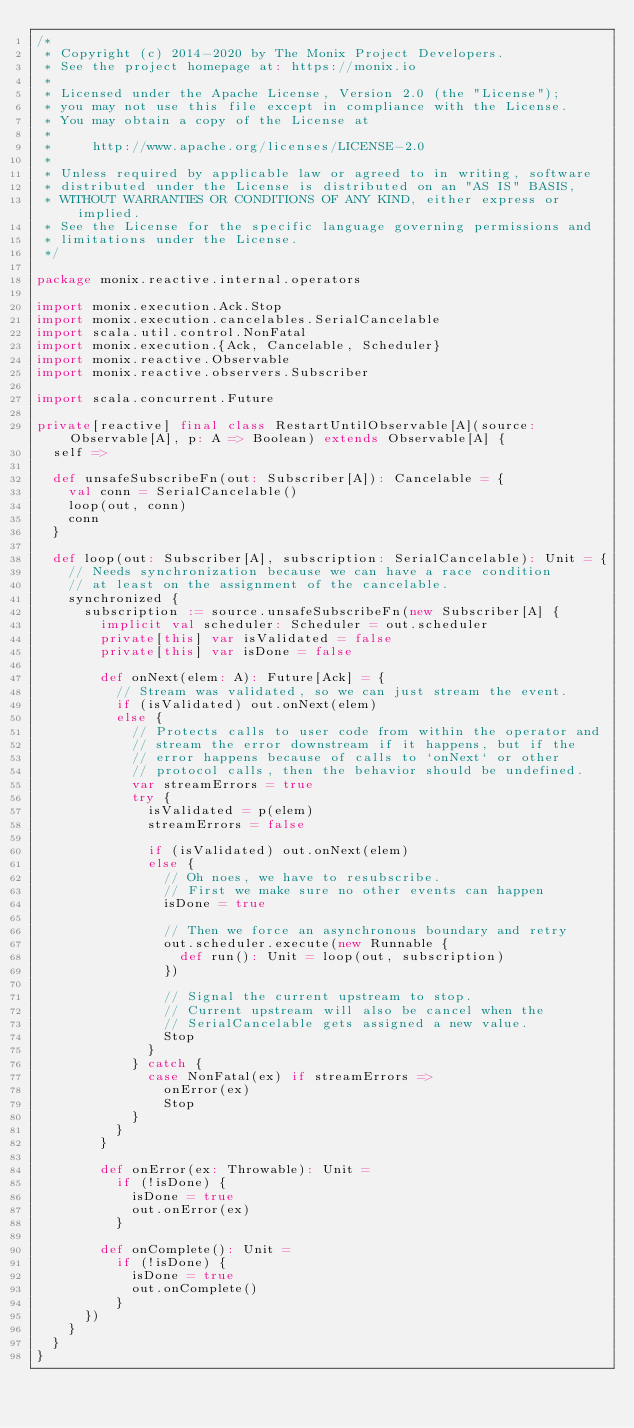<code> <loc_0><loc_0><loc_500><loc_500><_Scala_>/*
 * Copyright (c) 2014-2020 by The Monix Project Developers.
 * See the project homepage at: https://monix.io
 *
 * Licensed under the Apache License, Version 2.0 (the "License");
 * you may not use this file except in compliance with the License.
 * You may obtain a copy of the License at
 *
 *     http://www.apache.org/licenses/LICENSE-2.0
 *
 * Unless required by applicable law or agreed to in writing, software
 * distributed under the License is distributed on an "AS IS" BASIS,
 * WITHOUT WARRANTIES OR CONDITIONS OF ANY KIND, either express or implied.
 * See the License for the specific language governing permissions and
 * limitations under the License.
 */

package monix.reactive.internal.operators

import monix.execution.Ack.Stop
import monix.execution.cancelables.SerialCancelable
import scala.util.control.NonFatal
import monix.execution.{Ack, Cancelable, Scheduler}
import monix.reactive.Observable
import monix.reactive.observers.Subscriber

import scala.concurrent.Future

private[reactive] final class RestartUntilObservable[A](source: Observable[A], p: A => Boolean) extends Observable[A] {
  self =>

  def unsafeSubscribeFn(out: Subscriber[A]): Cancelable = {
    val conn = SerialCancelable()
    loop(out, conn)
    conn
  }

  def loop(out: Subscriber[A], subscription: SerialCancelable): Unit = {
    // Needs synchronization because we can have a race condition
    // at least on the assignment of the cancelable.
    synchronized {
      subscription := source.unsafeSubscribeFn(new Subscriber[A] {
        implicit val scheduler: Scheduler = out.scheduler
        private[this] var isValidated = false
        private[this] var isDone = false

        def onNext(elem: A): Future[Ack] = {
          // Stream was validated, so we can just stream the event.
          if (isValidated) out.onNext(elem)
          else {
            // Protects calls to user code from within the operator and
            // stream the error downstream if it happens, but if the
            // error happens because of calls to `onNext` or other
            // protocol calls, then the behavior should be undefined.
            var streamErrors = true
            try {
              isValidated = p(elem)
              streamErrors = false

              if (isValidated) out.onNext(elem)
              else {
                // Oh noes, we have to resubscribe.
                // First we make sure no other events can happen
                isDone = true

                // Then we force an asynchronous boundary and retry
                out.scheduler.execute(new Runnable {
                  def run(): Unit = loop(out, subscription)
                })

                // Signal the current upstream to stop.
                // Current upstream will also be cancel when the
                // SerialCancelable gets assigned a new value.
                Stop
              }
            } catch {
              case NonFatal(ex) if streamErrors =>
                onError(ex)
                Stop
            }
          }
        }

        def onError(ex: Throwable): Unit =
          if (!isDone) {
            isDone = true
            out.onError(ex)
          }

        def onComplete(): Unit =
          if (!isDone) {
            isDone = true
            out.onComplete()
          }
      })
    }
  }
}
</code> 